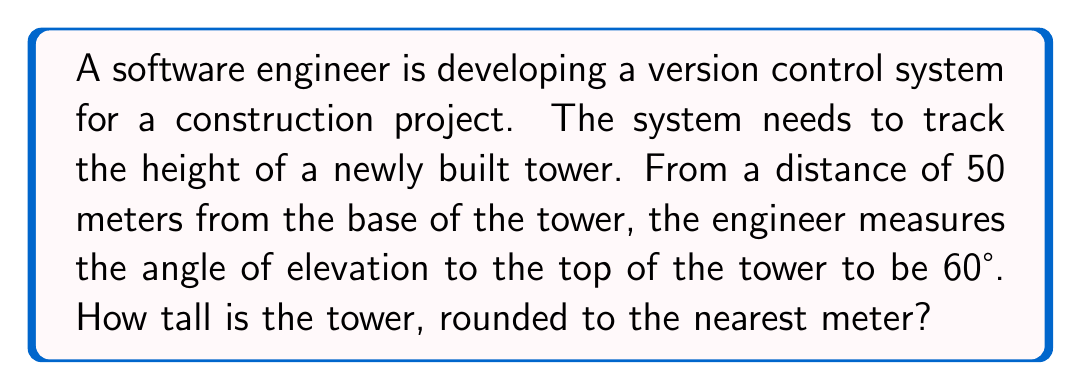Can you answer this question? Let's approach this step-by-step:

1) We can visualize this problem as a right triangle, where:
   - The base of the triangle is the distance from the engineer to the tower (50 m)
   - The height of the triangle is the height of the tower (what we're solving for)
   - The angle between the base and the hypotenuse is the angle of elevation (60°)

2) In this scenario, we're using the tangent ratio. Tangent is defined as the ratio of the opposite side to the adjacent side in a right triangle.

3) Let's define our variables:
   $h$ = height of the tower
   $d$ = distance from the engineer to the tower = 50 m
   $\theta$ = angle of elevation = 60°

4) The tangent ratio is:

   $$\tan \theta = \frac{\text{opposite}}{\text{adjacent}} = \frac{h}{d}$$

5) Substituting our known values:

   $$\tan 60° = \frac{h}{50}$$

6) We know that $\tan 60° = \sqrt{3}$, so:

   $$\sqrt{3} = \frac{h}{50}$$

7) Solving for $h$:

   $$h = 50 \sqrt{3}$$

8) Calculating this:

   $$h = 50 * 1.732050808 \approx 86.60254038$$

9) Rounding to the nearest meter:

   $$h \approx 87 \text{ meters}$$
Answer: 87 meters 